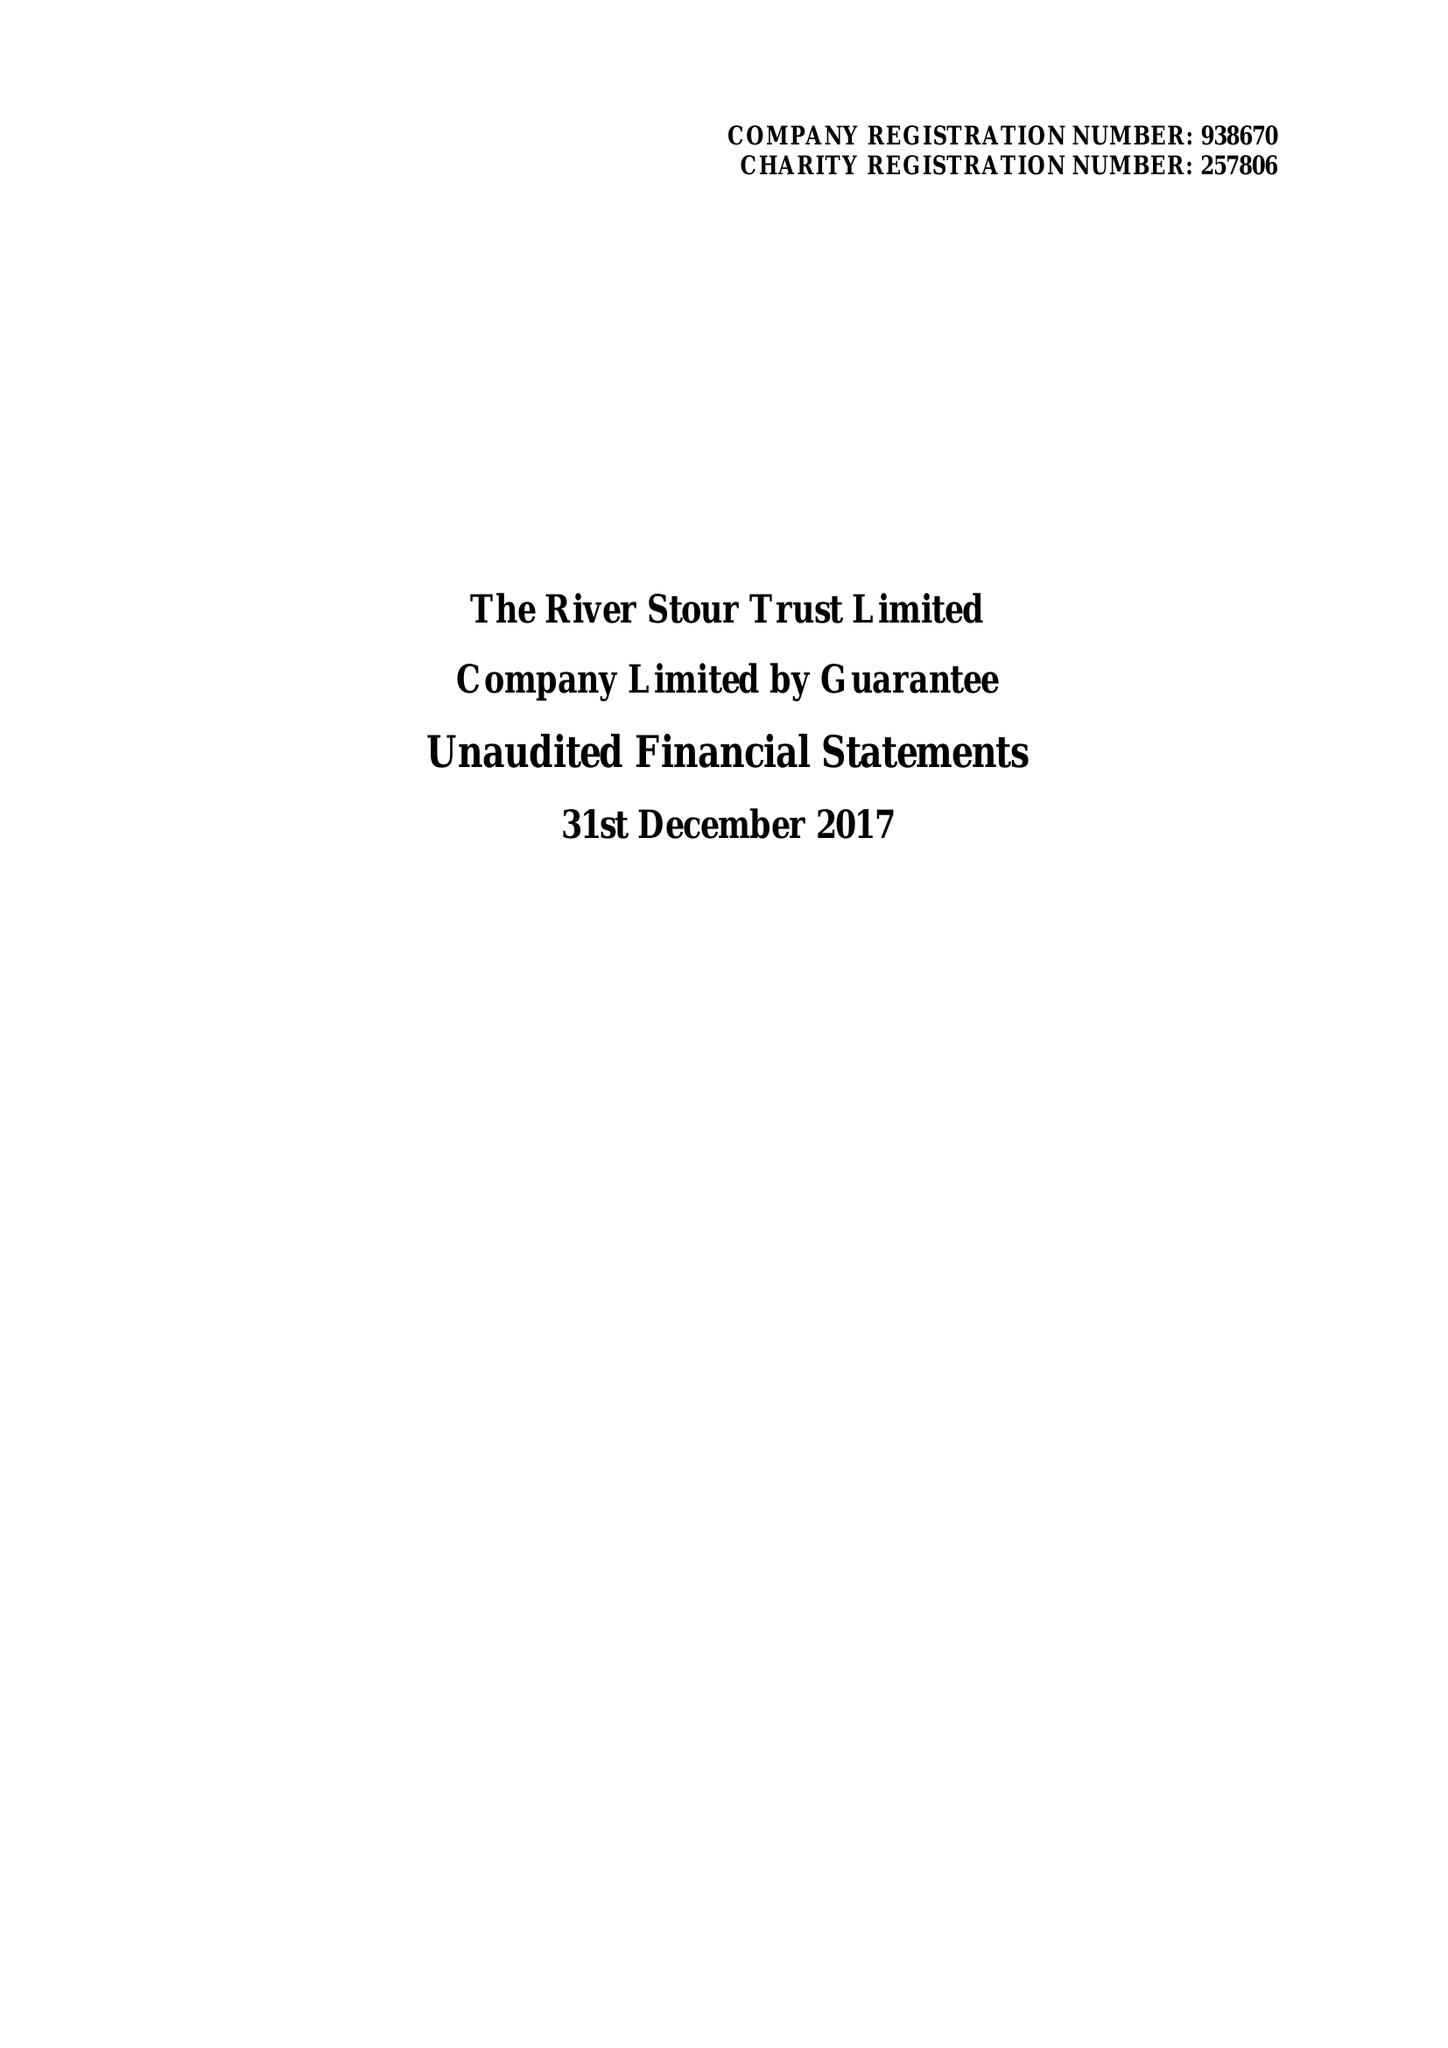What is the value for the charity_number?
Answer the question using a single word or phrase. 257806 